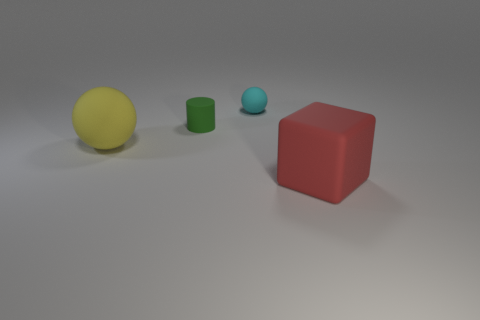What material is the tiny cyan object?
Your response must be concise. Rubber. There is a rubber thing that is both on the right side of the yellow thing and in front of the tiny green rubber object; what is its size?
Ensure brevity in your answer.  Large. How many small green matte objects are there?
Make the answer very short. 1. Are there fewer small cyan objects than small yellow rubber objects?
Make the answer very short. No. There is a sphere that is the same size as the red cube; what is its material?
Ensure brevity in your answer.  Rubber. How many objects are large red balls or red blocks?
Provide a short and direct response. 1. What number of large rubber objects are to the right of the large yellow matte thing and to the left of the large red block?
Your response must be concise. 0. Are there fewer cyan rubber things that are on the left side of the big yellow thing than tiny gray things?
Provide a succinct answer. No. The other thing that is the same size as the red thing is what shape?
Your answer should be very brief. Sphere. What number of other objects are there of the same color as the matte cube?
Provide a short and direct response. 0. 